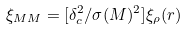<formula> <loc_0><loc_0><loc_500><loc_500>\xi _ { M M } = [ \delta _ { c } ^ { 2 } / \sigma ( M ) ^ { 2 } ] \xi _ { \rho } ( r )</formula> 